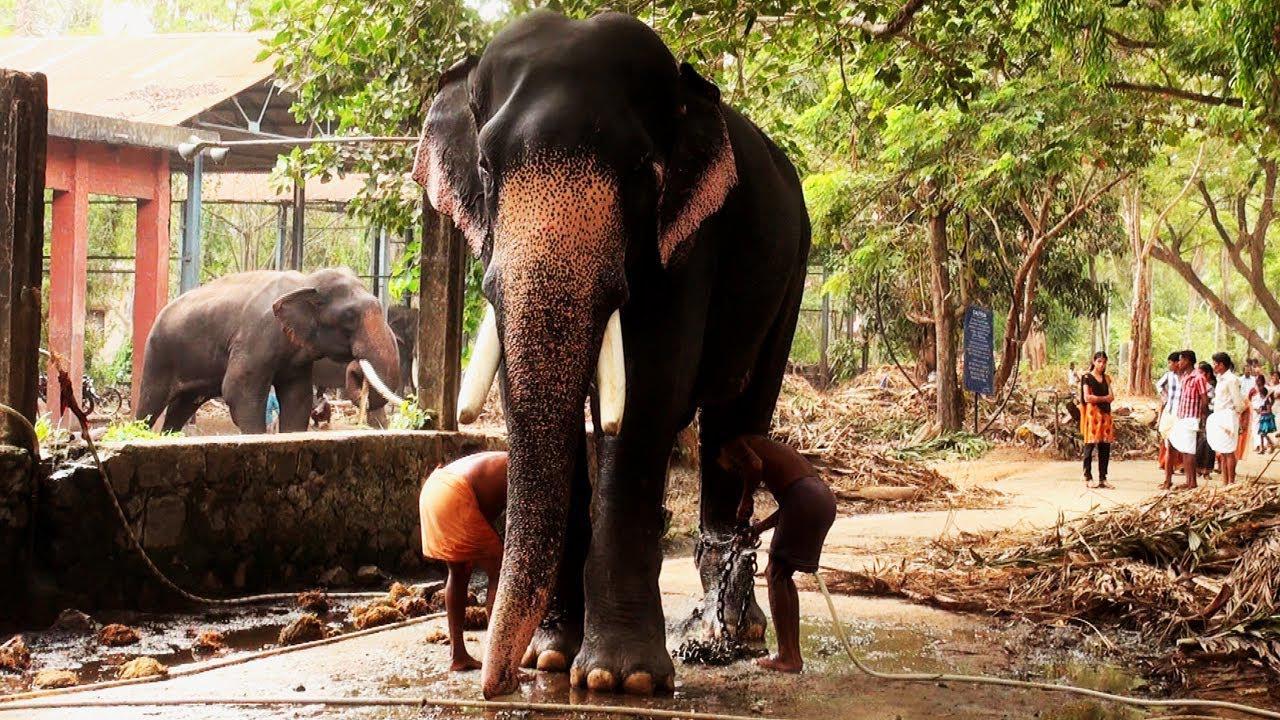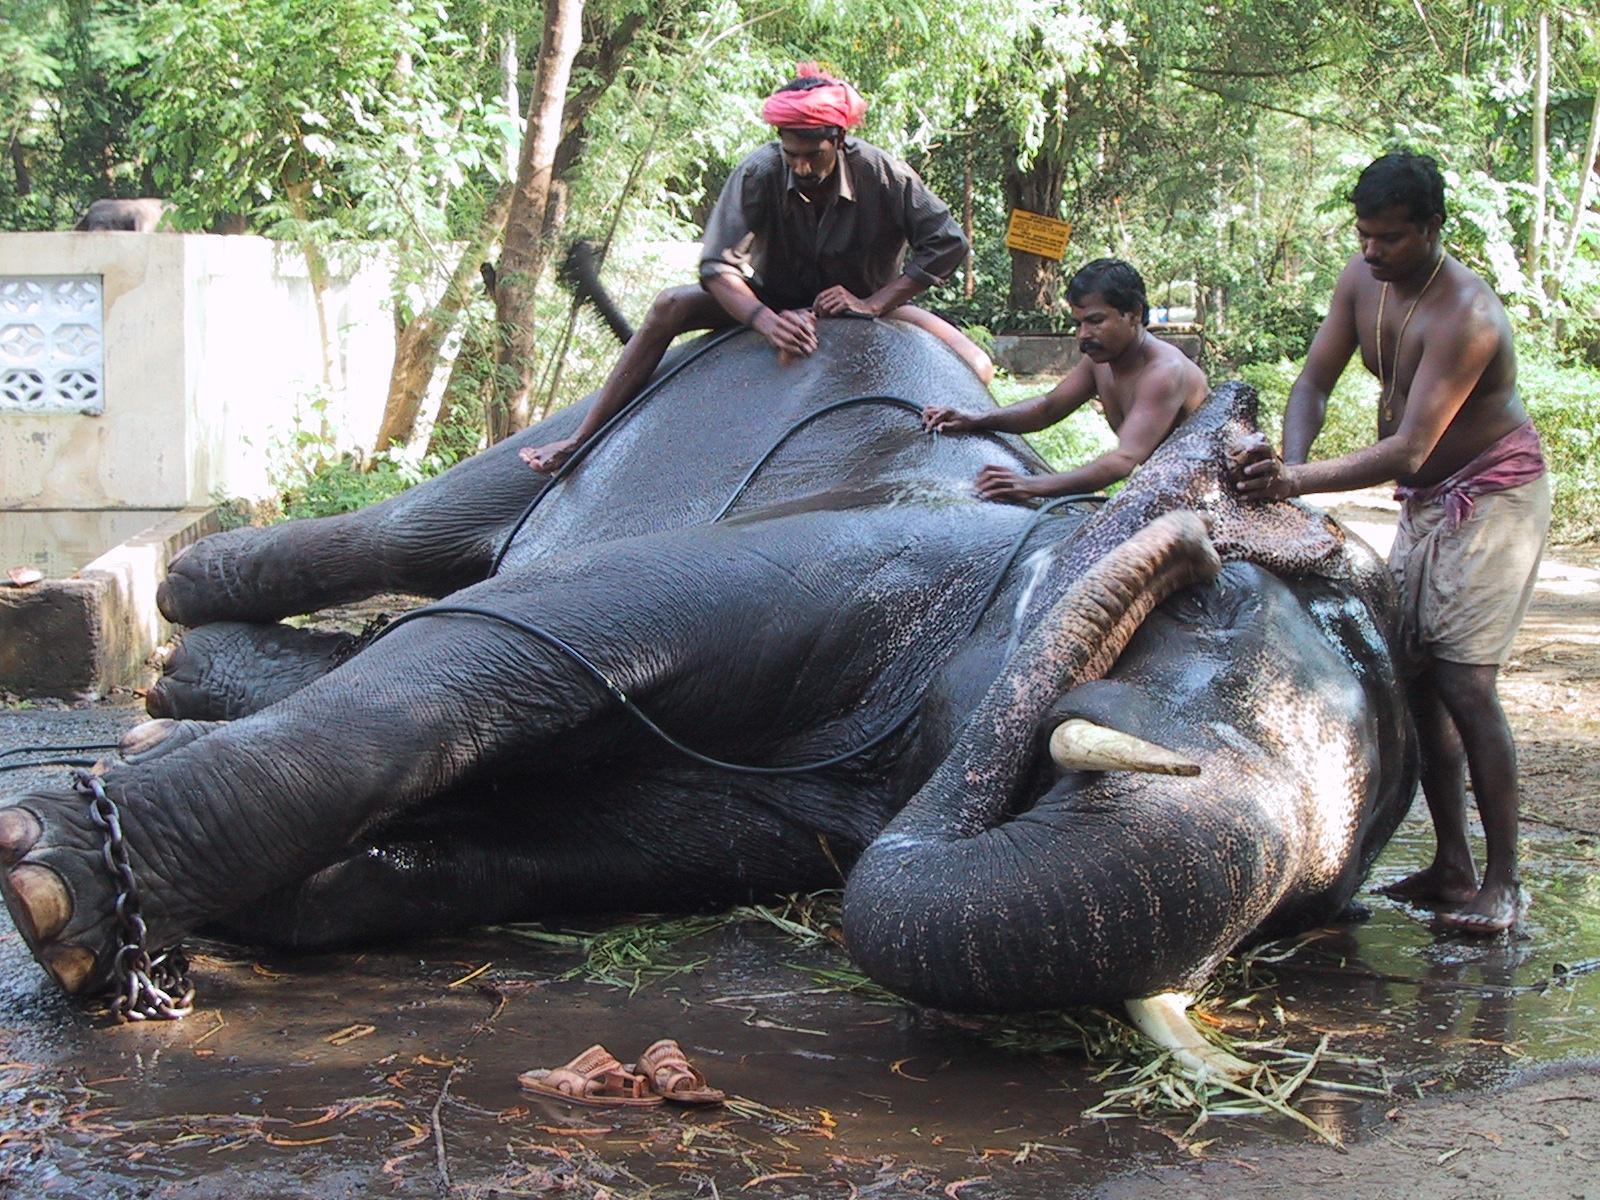The first image is the image on the left, the second image is the image on the right. Examine the images to the left and right. Is the description "At least one of the images shows people interacting with an elephant." accurate? Answer yes or no. Yes. The first image is the image on the left, the second image is the image on the right. Evaluate the accuracy of this statement regarding the images: "At least one image shows people near an elephant with chained feet.". Is it true? Answer yes or no. Yes. 